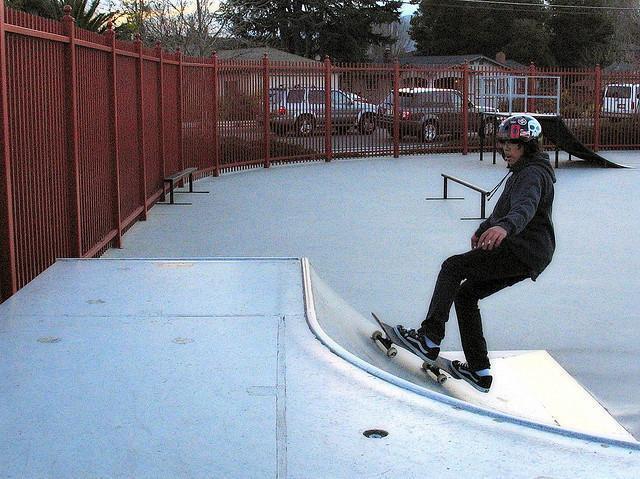How many cars can be seen?
Give a very brief answer. 2. How many of the trucks doors are open?
Give a very brief answer. 0. 